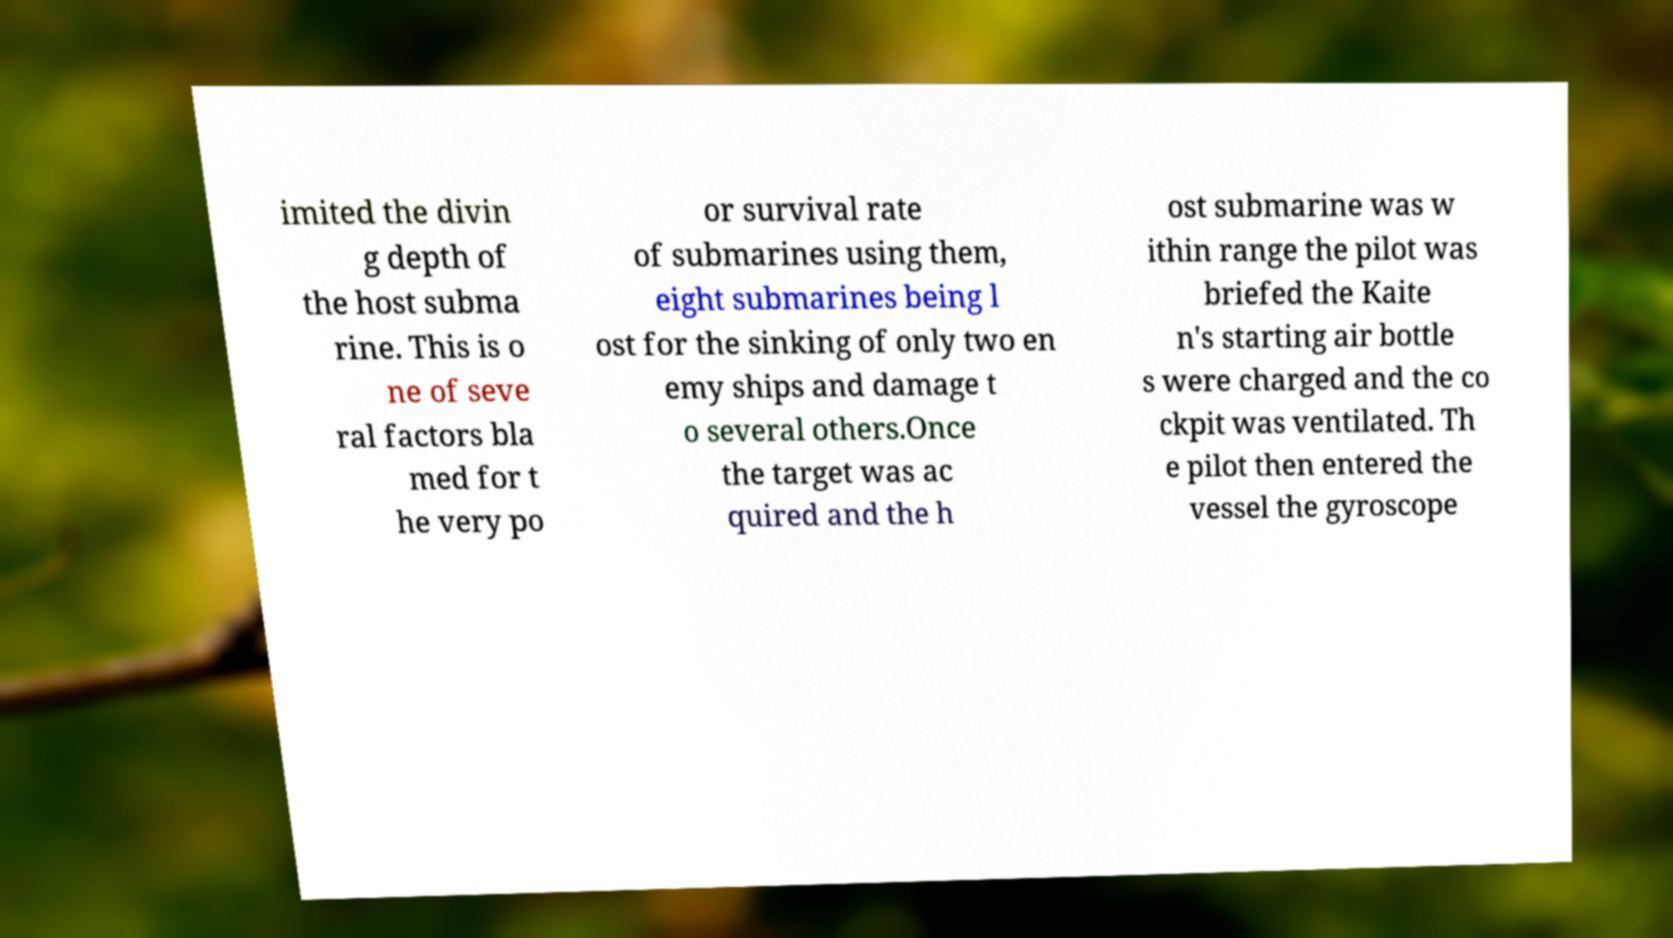Please identify and transcribe the text found in this image. imited the divin g depth of the host subma rine. This is o ne of seve ral factors bla med for t he very po or survival rate of submarines using them, eight submarines being l ost for the sinking of only two en emy ships and damage t o several others.Once the target was ac quired and the h ost submarine was w ithin range the pilot was briefed the Kaite n's starting air bottle s were charged and the co ckpit was ventilated. Th e pilot then entered the vessel the gyroscope 